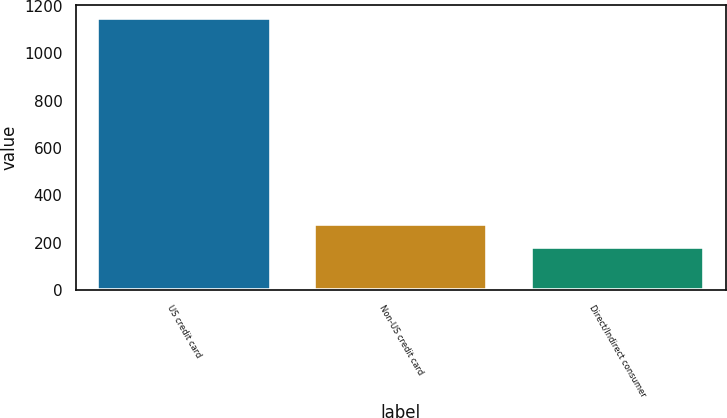Convert chart to OTSL. <chart><loc_0><loc_0><loc_500><loc_500><bar_chart><fcel>US credit card<fcel>Non-US credit card<fcel>Direct/Indirect consumer<nl><fcel>1148<fcel>276.8<fcel>180<nl></chart> 